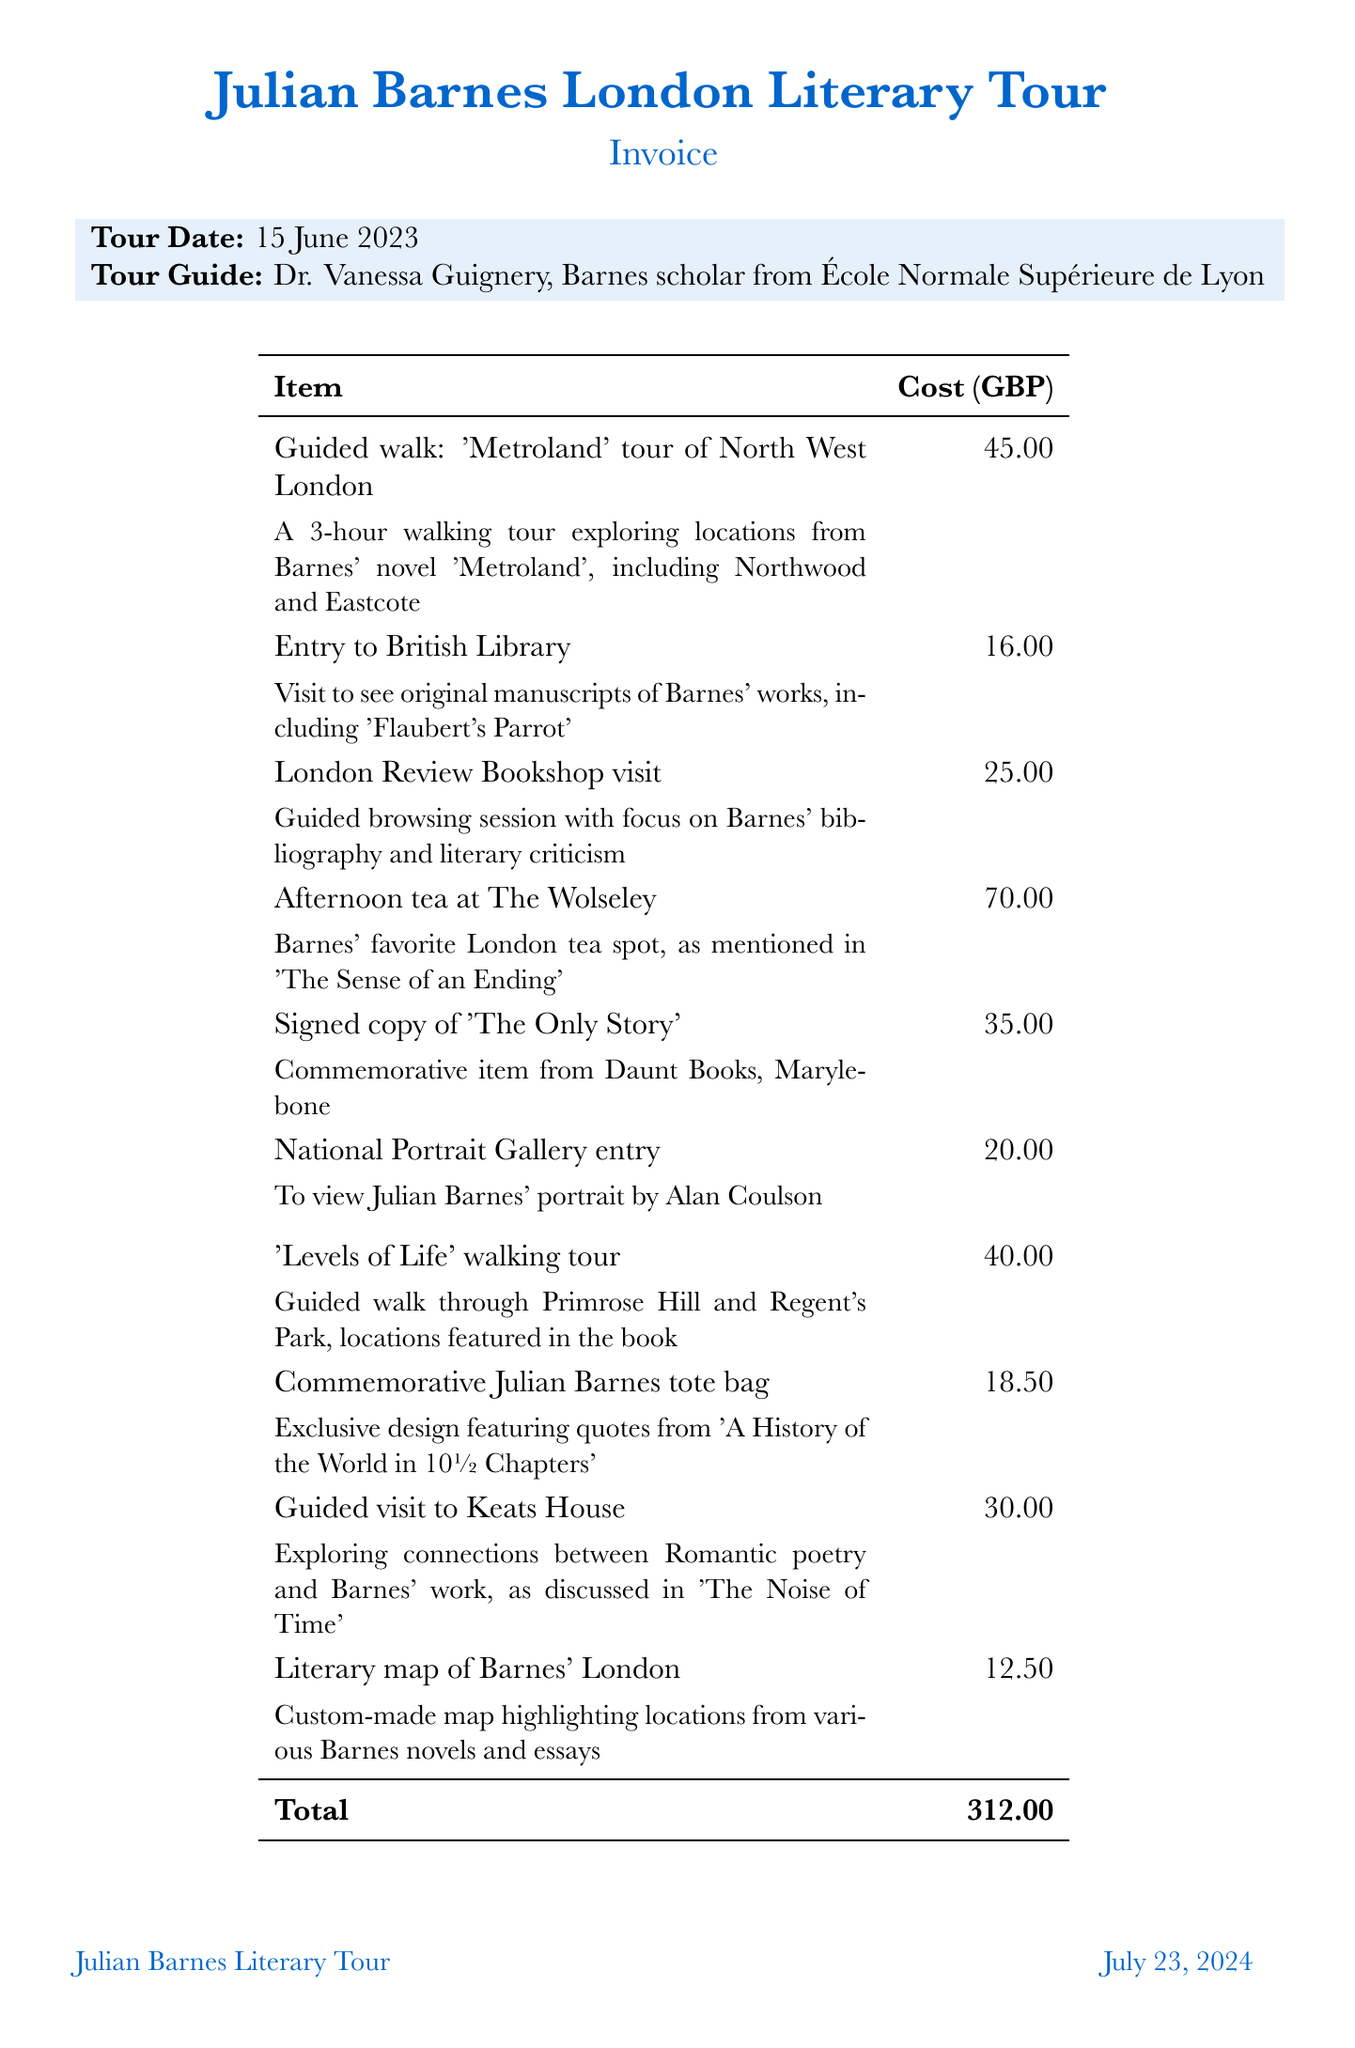What is the total cost of the tour? The total cost is explicitly listed at the bottom of the invoice as the cumulative amount of all items.
Answer: 312.00 Who was the tour guide? The name and credentials of the tour guide are provided in the tour details section of the invoice.
Answer: Dr. Vanessa Guignery What date was the tour given? The tour date is mentioned in the invoice details right at the beginning under the tour information.
Answer: 15 June 2023 How much did the signed copy of 'The Only Story' cost? The cost of each individual item is listed next to the description, specifically for this commemorative item.
Answer: 35.00 Which location features Barnes' portrait? The document specifies which gallery has the portrait as part of the item description.
Answer: National Portrait Gallery How many guided walks are included in the invoice? The guided walks are listed as separate items, allowing for easy counting of how many are present.
Answer: 2 What is the description of the tote bag? The description of the tote bag item provides details on its design and literary significance.
Answer: Exclusive design featuring quotes from 'A History of the World in 10½ Chapters' How much is the entry to the British Library? The entry fee for the British Library is provided in the cost breakdown for each item listed on the invoice.
Answer: 16.00 What type of dining experience is included in the invoice? The invoice mentions a specific dining location and type of experience, indicating a culinary activity tied to Barnes.
Answer: Afternoon tea at The Wolseley 